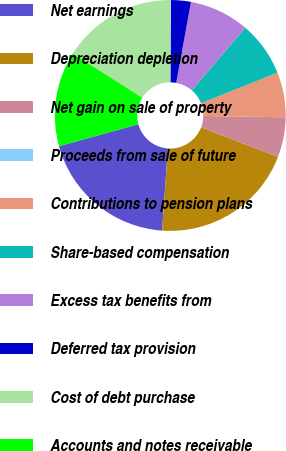Convert chart. <chart><loc_0><loc_0><loc_500><loc_500><pie_chart><fcel>Net earnings<fcel>Depreciation depletion<fcel>Net gain on sale of property<fcel>Proceeds from sale of future<fcel>Contributions to pension plans<fcel>Share-based compensation<fcel>Excess tax benefits from<fcel>Deferred tax provision<fcel>Cost of debt purchase<fcel>Accounts and notes receivable<nl><fcel>19.58%<fcel>20.28%<fcel>5.59%<fcel>0.0%<fcel>6.29%<fcel>7.69%<fcel>8.39%<fcel>2.8%<fcel>16.08%<fcel>13.29%<nl></chart> 